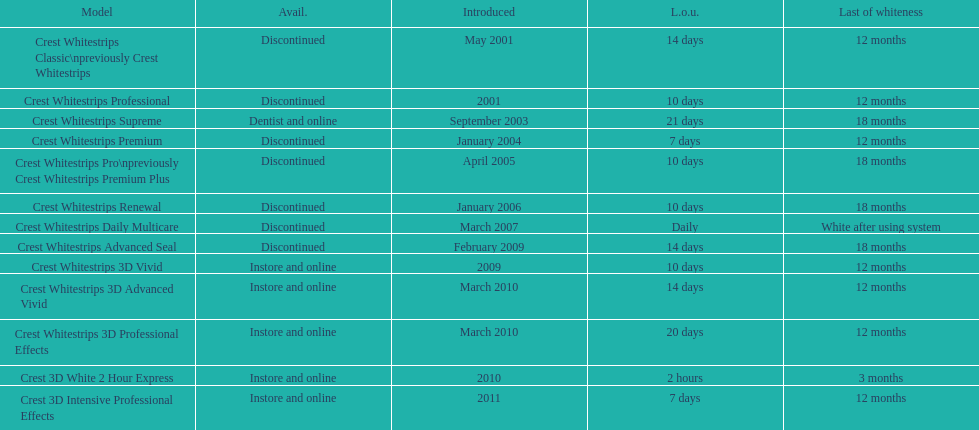Which product was launched alongside crest whitestrips 3d advanced vivid in the same month? Crest Whitestrips 3D Professional Effects. 